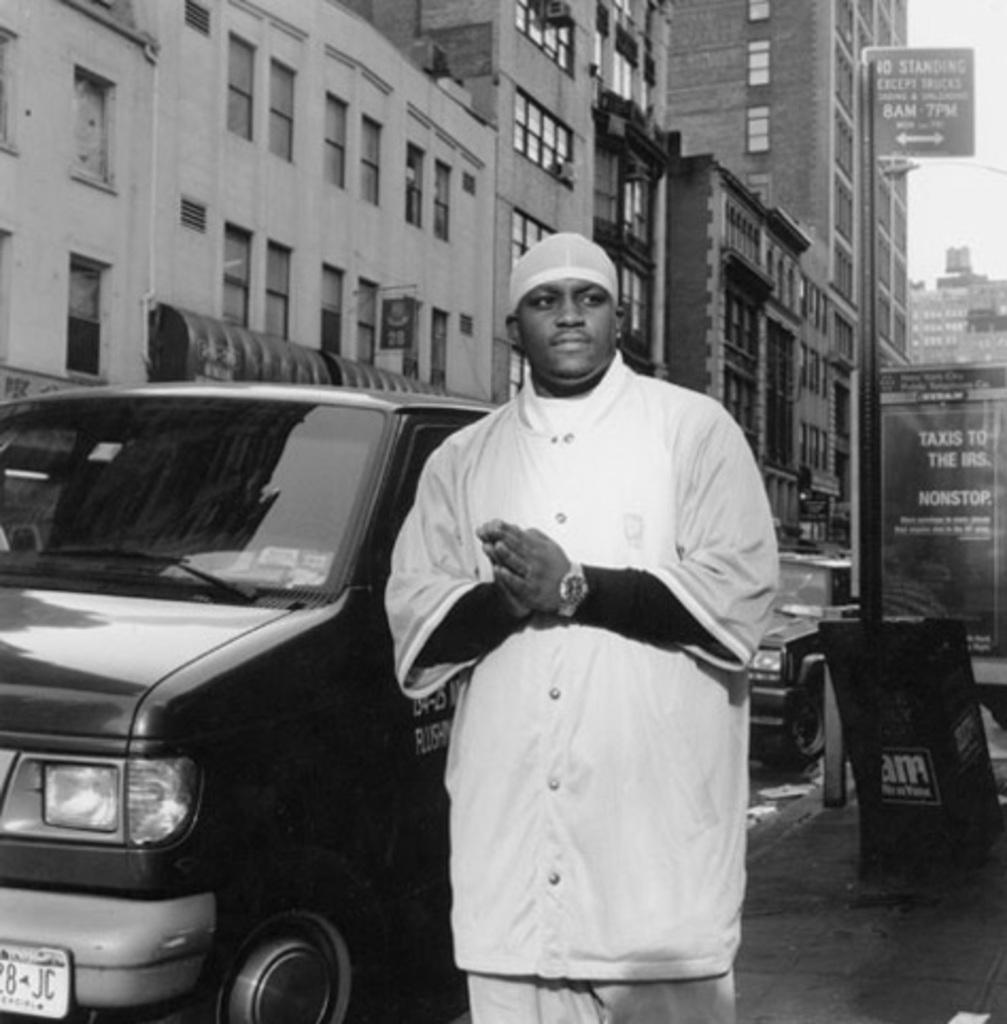<image>
Give a short and clear explanation of the subsequent image. A man in a white uniform and hat stands by a van near a sign that says no standing except trucks. 